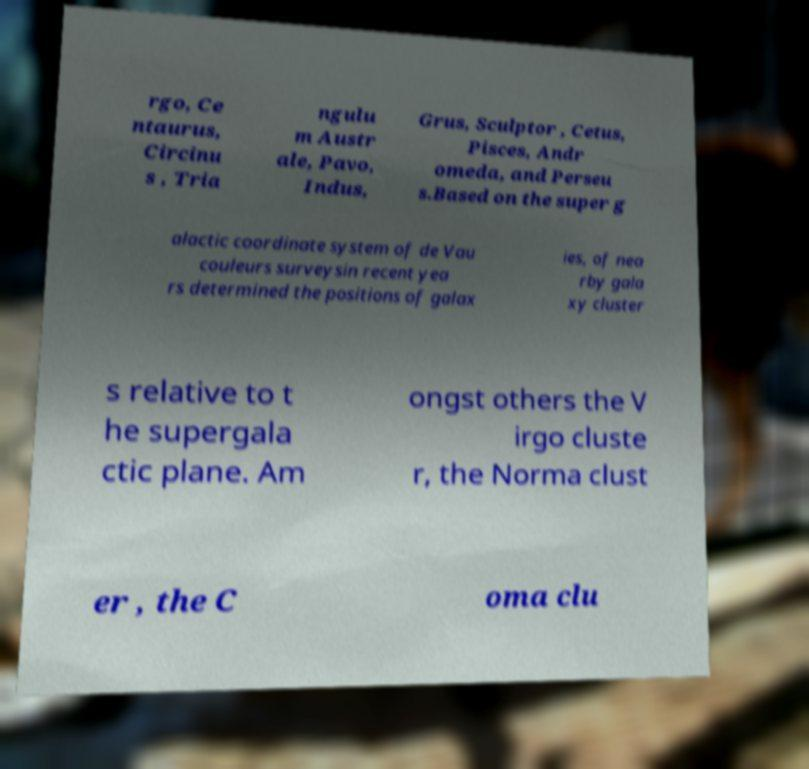I need the written content from this picture converted into text. Can you do that? rgo, Ce ntaurus, Circinu s , Tria ngulu m Austr ale, Pavo, Indus, Grus, Sculptor , Cetus, Pisces, Andr omeda, and Perseu s.Based on the super g alactic coordinate system of de Vau couleurs surveysin recent yea rs determined the positions of galax ies, of nea rby gala xy cluster s relative to t he supergala ctic plane. Am ongst others the V irgo cluste r, the Norma clust er , the C oma clu 